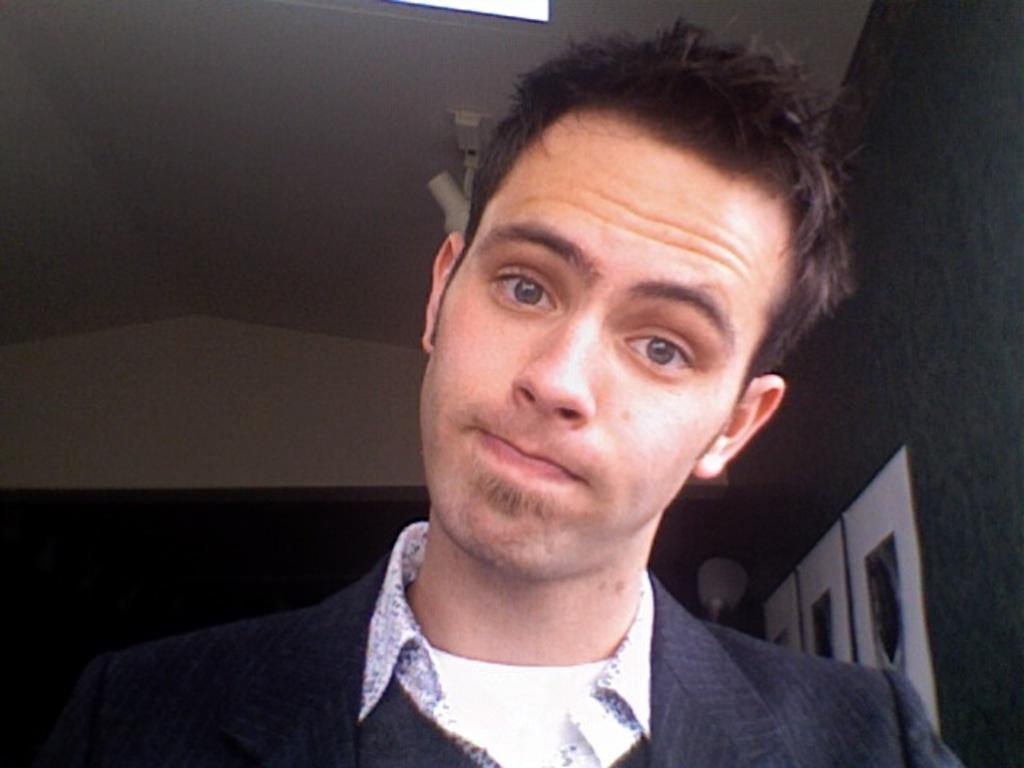Who is present in the image? There is a man in the image. What is the man wearing? The man is wearing a blazer. What can be seen on the wall behind the man? There are frames on the wall behind the man. Can you describe any objects visible in the image? There are objects visible in the image, but their specific details are not mentioned in the provided facts. What color is the yak sitting on the sofa in the image? There is no yak or sofa present in the image. What is the likelihood of the man winning a chance game in the image? The provided facts do not mention any chance games or the man's likelihood of winning, so it cannot be determined from the image. 